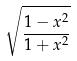Convert formula to latex. <formula><loc_0><loc_0><loc_500><loc_500>\sqrt { \frac { 1 - x ^ { 2 } } { 1 + x ^ { 2 } } }</formula> 